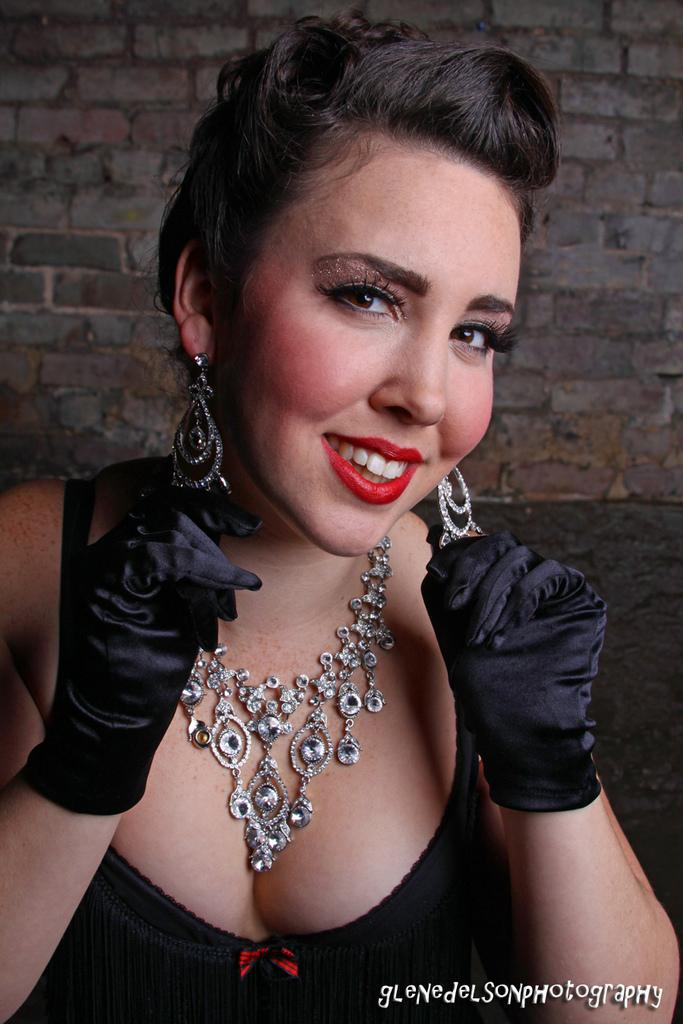Who is present in the image? There is a woman in the image. What is the woman wearing on her ears and neck? The woman is wearing ornaments on her ears and neck. What is the woman wearing on her hands? The woman is wearing gloves on her hands. What is the woman's facial expression in the image? The woman is smiling. What can be seen in the background of the image? There is a brick wall in the background of the image. How many pockets can be seen on the woman's clothing in the image? There is no information about pockets on the woman's clothing in the image. What type of earth is visible in the image? There is no earth visible in the image; it features a woman and a brick wall in the background. 